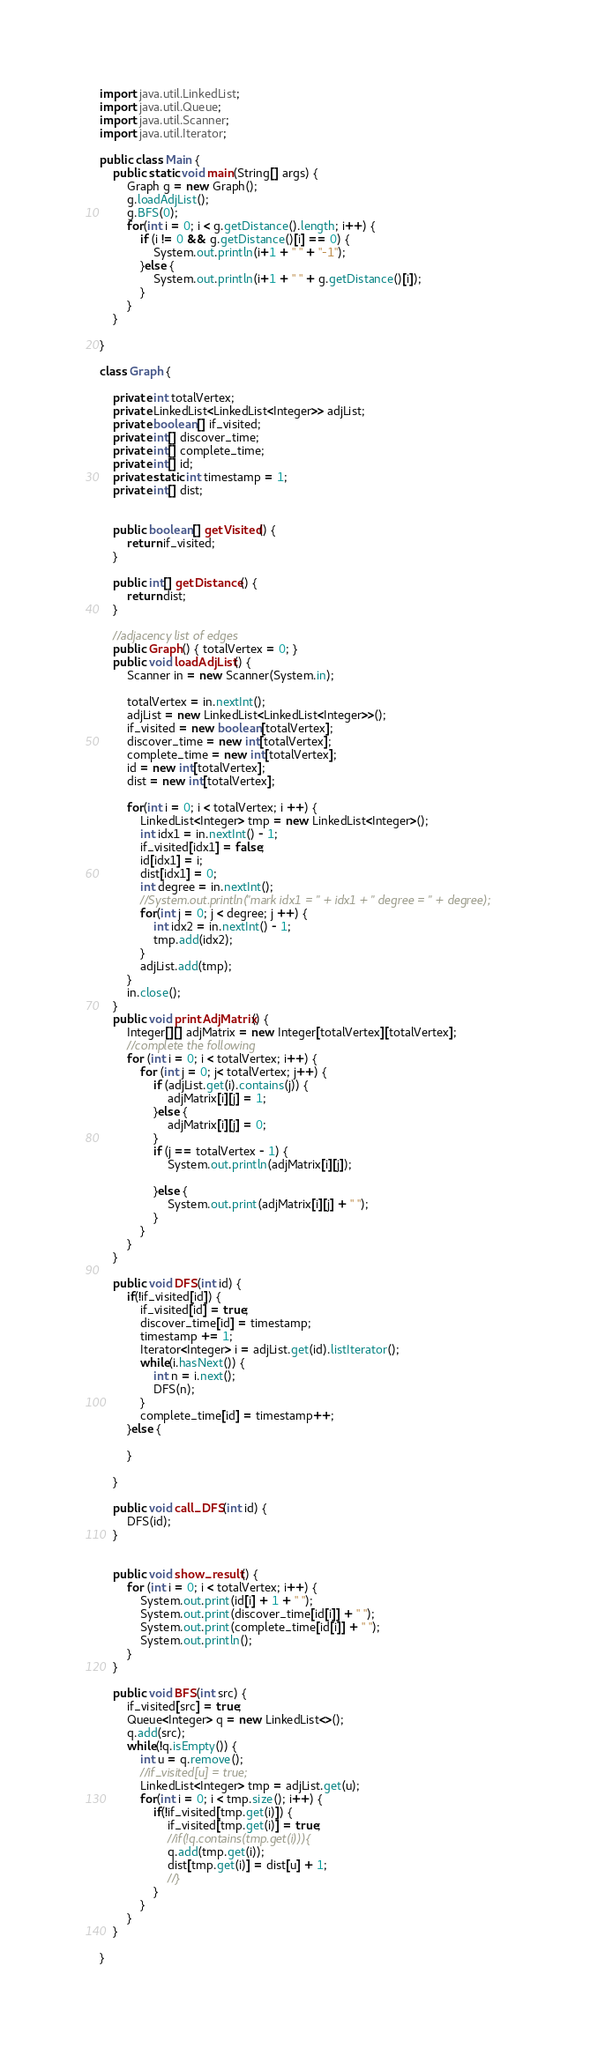Convert code to text. <code><loc_0><loc_0><loc_500><loc_500><_Java_>import java.util.LinkedList;
import java.util.Queue;
import java.util.Scanner;
import java.util.Iterator;

public class Main {
	public static void main(String[] args) {
		Graph g = new Graph();
		g.loadAdjList();
		g.BFS(0);
		for(int i = 0; i < g.getDistance().length; i++) {
			if (i != 0 && g.getDistance()[i] == 0) {
				System.out.println(i+1 + " " + "-1");
			}else {
				System.out.println(i+1 + " " + g.getDistance()[i]);
			}
		}
	}
	
}

class Graph {
	
	private int totalVertex;
	private LinkedList<LinkedList<Integer>> adjList;
	private boolean[] if_visited;
	private int[] discover_time;
	private int[] complete_time;
	private int[] id;
	private static int timestamp = 1;
	private int[] dist;
	
	
	public boolean[] getVisited() {
		return if_visited;
	}
	
	public int[] getDistance() {
		return dist;
	}
	
	//adjacency list of edges
	public Graph() { totalVertex = 0; }
	public void loadAdjList() {
		Scanner in = new Scanner(System.in);
		
		totalVertex = in.nextInt();
		adjList = new LinkedList<LinkedList<Integer>>();
		if_visited = new boolean[totalVertex];
		discover_time = new int[totalVertex];
		complete_time = new int[totalVertex];
		id = new int[totalVertex];
		dist = new int[totalVertex];
		
		for(int i = 0; i < totalVertex; i ++) {
			LinkedList<Integer> tmp = new LinkedList<Integer>();
			int idx1 = in.nextInt() - 1;
			if_visited[idx1] = false;
			id[idx1] = i;
			dist[idx1] = 0;
			int degree = in.nextInt();
			//System.out.println("mark idx1 = " + idx1 + " degree = " + degree);
			for(int j = 0; j < degree; j ++) {
				int idx2 = in.nextInt() - 1;
				tmp.add(idx2);
			}	
			adjList.add(tmp);
		}
		in.close();
	}
	public void printAdjMatrix() {
		Integer[][] adjMatrix = new Integer[totalVertex][totalVertex];
		//complete the following
		for (int i = 0; i < totalVertex; i++) {
			for (int j = 0; j< totalVertex; j++) {
				if (adjList.get(i).contains(j)) {
					adjMatrix[i][j] = 1;
				}else {
					adjMatrix[i][j] = 0;				
				}
				if (j == totalVertex - 1) {
					System.out.println(adjMatrix[i][j]);
					
				}else {
					System.out.print(adjMatrix[i][j] + " ");
				}
			}
		}
	}
	
	public void DFS(int id) {
		if(!if_visited[id]) {
			if_visited[id] = true;
			discover_time[id] = timestamp;
			timestamp += 1;
			Iterator<Integer> i = adjList.get(id).listIterator();
			while(i.hasNext()) {
				int n = i.next();
				DFS(n);
			}
			complete_time[id] = timestamp++;
		}else {
			
		}
		
	}
	
	public void call_DFS(int id) {
		DFS(id);
	}
	
	
	public void show_result() {
		for (int i = 0; i < totalVertex; i++) {
			System.out.print(id[i] + 1 + " ");
			System.out.print(discover_time[id[i]] + " ");
			System.out.print(complete_time[id[i]] + " ");
			System.out.println();
		}
	}
	
	public void BFS(int src) {
		if_visited[src] = true;
		Queue<Integer> q = new LinkedList<>();
		q.add(src);
		while(!q.isEmpty()) {
			int u = q.remove();
			//if_visited[u] = true;
			LinkedList<Integer> tmp = adjList.get(u);
			for(int i = 0; i < tmp.size(); i++) {
				if(!if_visited[tmp.get(i)]) {
					if_visited[tmp.get(i)] = true;
					//if(!q.contains(tmp.get(i))){
					q.add(tmp.get(i));
					dist[tmp.get(i)] = dist[u] + 1;
					//}
				}
			}
		}
	}
	
}


</code> 